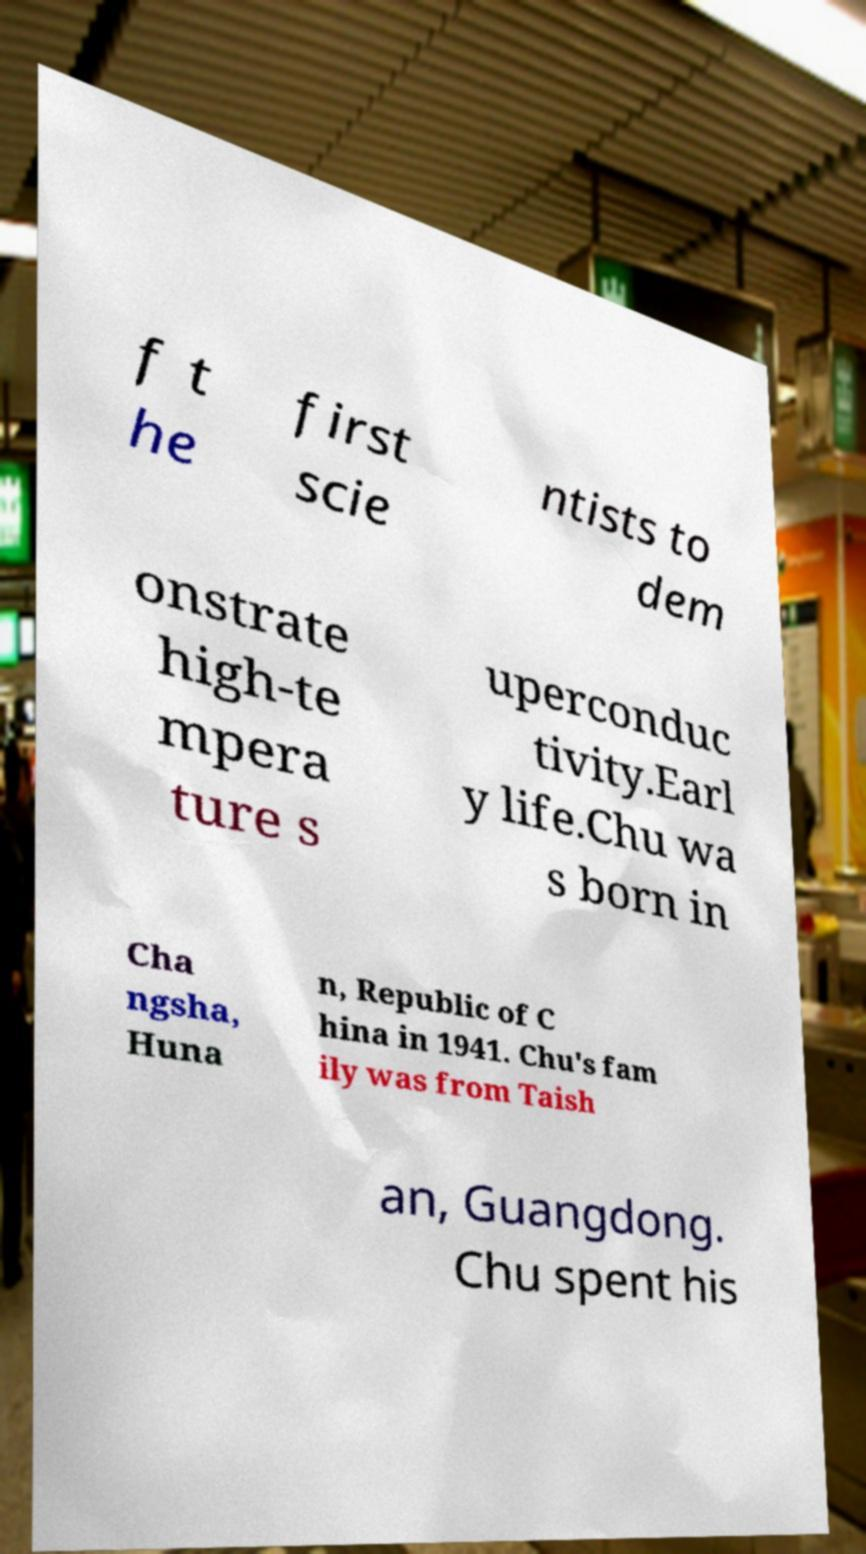Could you assist in decoding the text presented in this image and type it out clearly? f t he first scie ntists to dem onstrate high-te mpera ture s uperconduc tivity.Earl y life.Chu wa s born in Cha ngsha, Huna n, Republic of C hina in 1941. Chu's fam ily was from Taish an, Guangdong. Chu spent his 